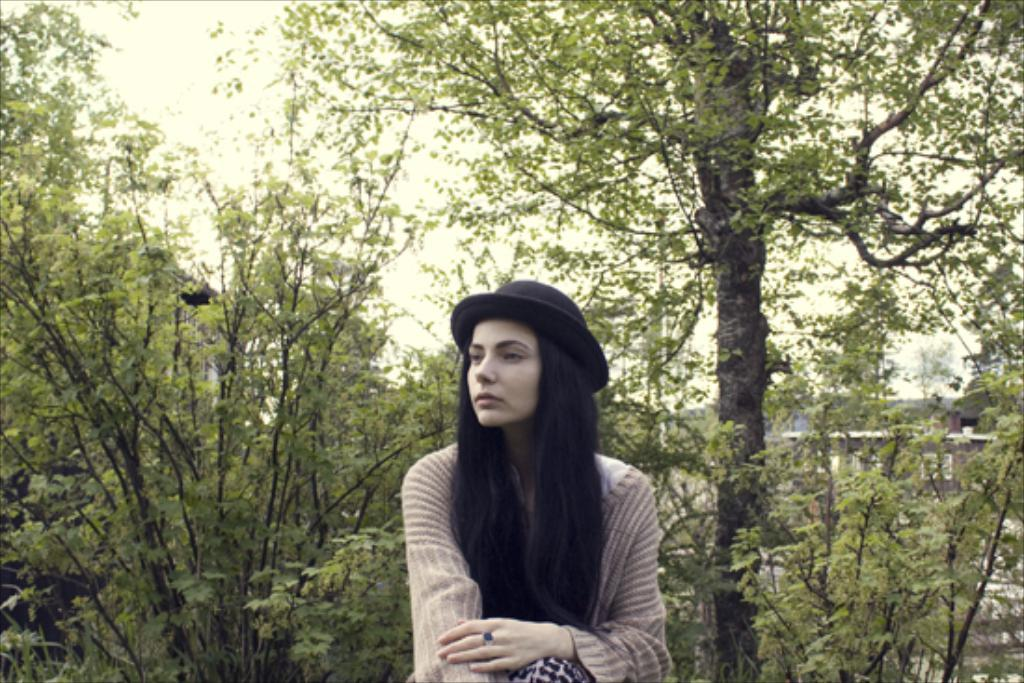Who is present in the image? There is a woman in the image. What type of natural environment can be seen in the image? There are trees in the image. What type of structure is visible in the image? There is a house in the image. What is visible in the background of the image? The sky is visible in the background of the image. What time is the train scheduled to arrive in the image? There is no train present in the image, so it is not possible to determine the arrival time of a train. 